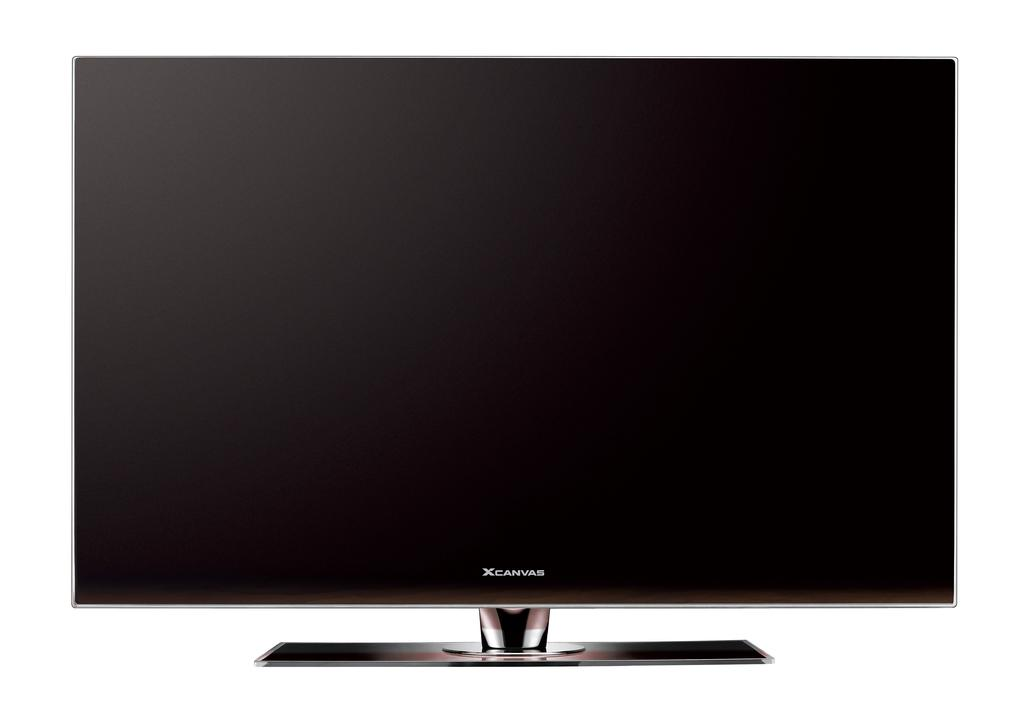<image>
Offer a succinct explanation of the picture presented. A shot of a xcanvas monitor with a blank screen 